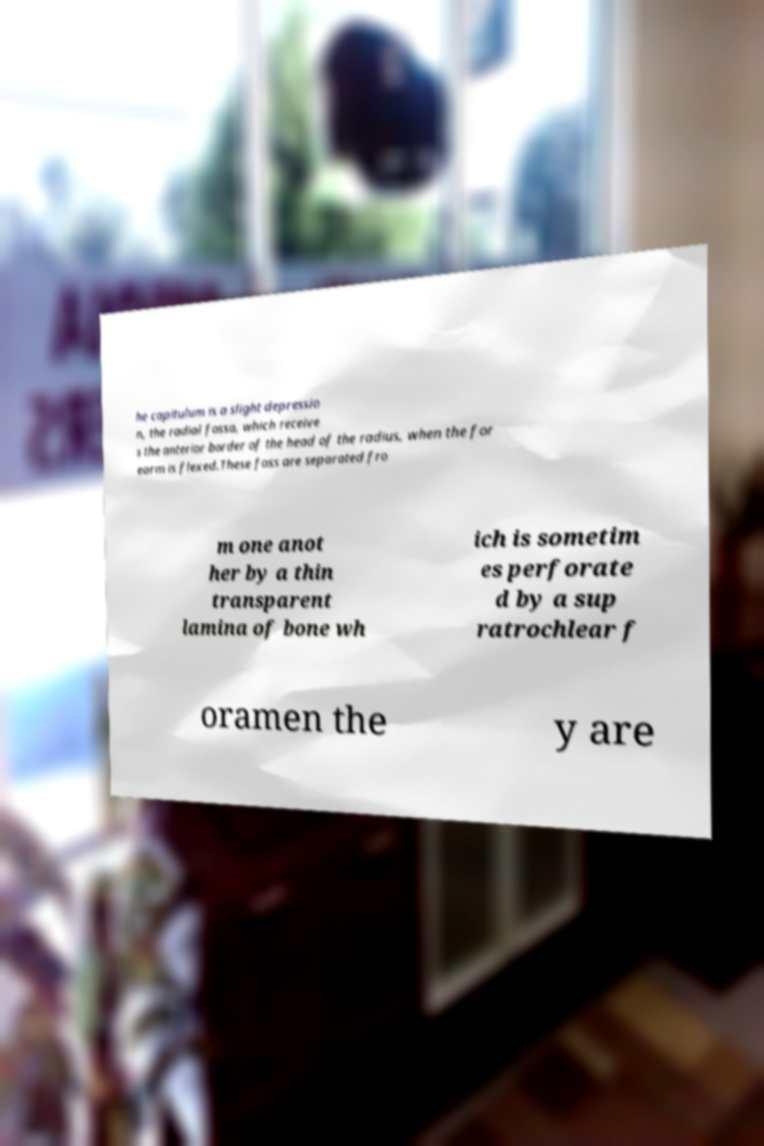Please identify and transcribe the text found in this image. he capitulum is a slight depressio n, the radial fossa, which receive s the anterior border of the head of the radius, when the for earm is flexed.These foss are separated fro m one anot her by a thin transparent lamina of bone wh ich is sometim es perforate d by a sup ratrochlear f oramen the y are 